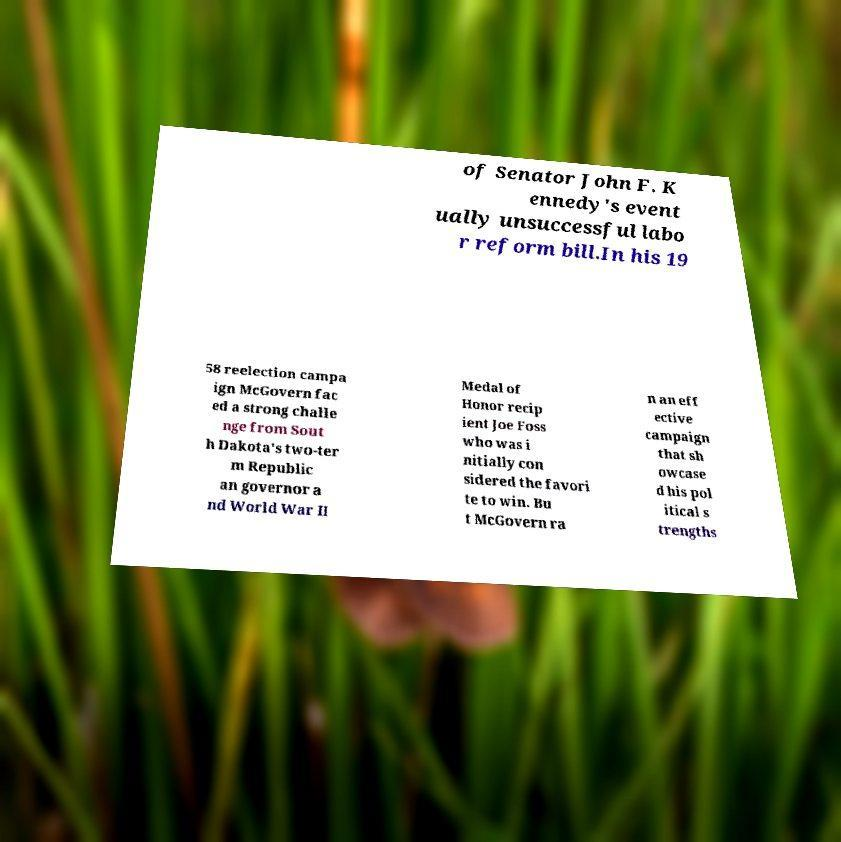Can you accurately transcribe the text from the provided image for me? of Senator John F. K ennedy's event ually unsuccessful labo r reform bill.In his 19 58 reelection campa ign McGovern fac ed a strong challe nge from Sout h Dakota's two-ter m Republic an governor a nd World War II Medal of Honor recip ient Joe Foss who was i nitially con sidered the favori te to win. Bu t McGovern ra n an eff ective campaign that sh owcase d his pol itical s trengths 